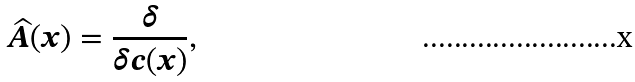Convert formula to latex. <formula><loc_0><loc_0><loc_500><loc_500>\widehat { A } ( x ) = \frac { \delta } { \delta c ( x ) } ,</formula> 